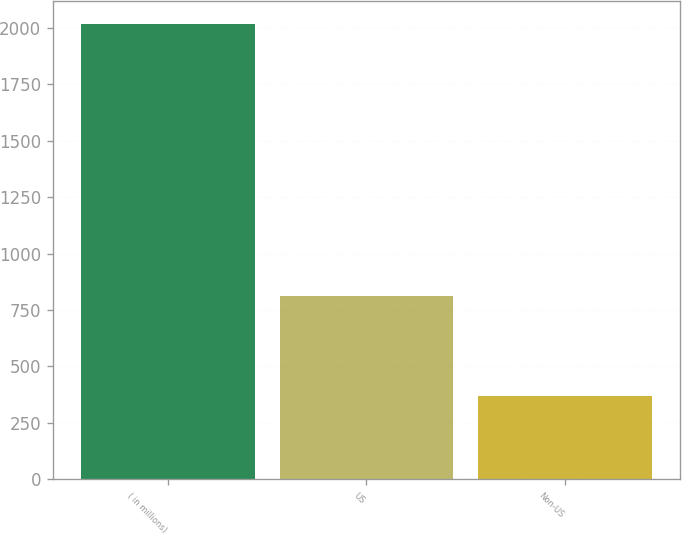Convert chart. <chart><loc_0><loc_0><loc_500><loc_500><bar_chart><fcel>( in millions)<fcel>US<fcel>Non-US<nl><fcel>2016<fcel>813<fcel>371<nl></chart> 